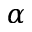Convert formula to latex. <formula><loc_0><loc_0><loc_500><loc_500>\alpha</formula> 